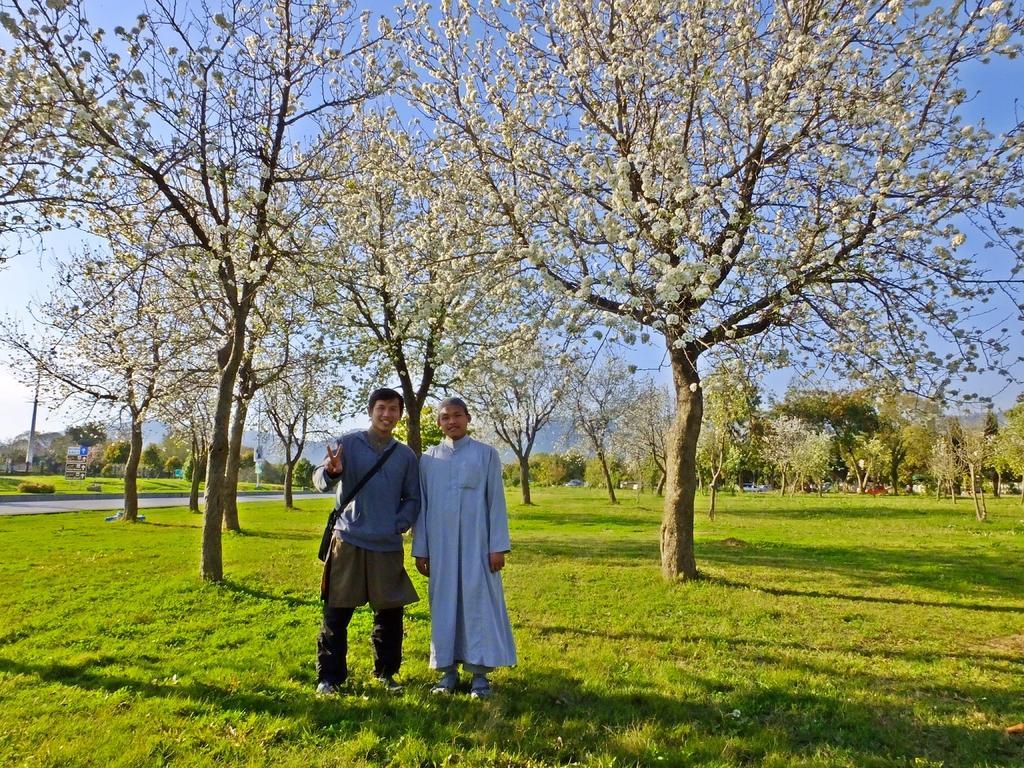Could you give a brief overview of what you see in this image? In the center of the image we can see two people standing. At the bottom there is grass. In the background there are trees, hills and sky. We can see boards. 